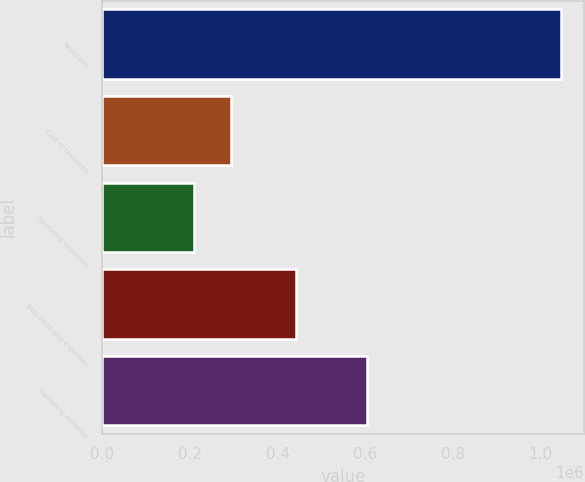<chart> <loc_0><loc_0><loc_500><loc_500><bar_chart><fcel>Revenues<fcel>Cost of revenues<fcel>Operating expenses<fcel>Total costs and expenses<fcel>Operating earnings<nl><fcel>1.04618e+06<fcel>293390<fcel>209747<fcel>441724<fcel>604456<nl></chart> 